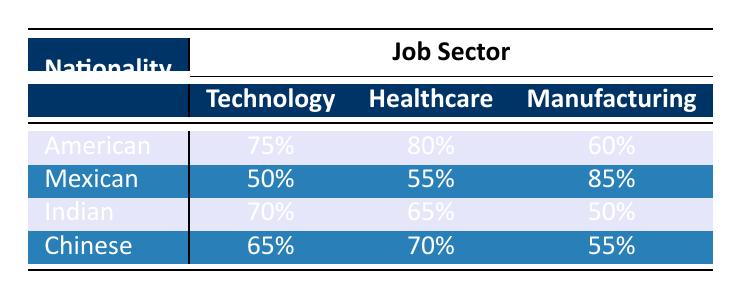What is the participation rate of Americans in the Healthcare sector? From the table, the row for Americans under the Healthcare sector shows a participation rate of 80%.
Answer: 80% Which nationality has the highest participation rate in the Manufacturing sector? In the Manufacturing sector, the participation rates are: American (60%), Mexican (85%), Indian (50%), Chinese (55%). The highest value is 85% for Mexicans.
Answer: Mexican What is the average participation rate for the Technology sector among all nationalities? For the Technology sector, the participation rates are: American (75%), Mexican (50%), Indian (70%), Chinese (65%). The sum is (75 + 50 + 70 + 65) = 260, and there are 4 nationalities, so the average is 260/4 = 65%.
Answer: 65% Is it true that Indians have a higher participation rate in Healthcare than Mexicans? The Healthcare participation rates are: Indian (65%), Mexican (55%). Since 65% is greater than 55%, the statement is true.
Answer: Yes Which job sector has the lowest participation rate for Mexicans? The participation rates for Mexicans are: Technology (50%), Healthcare (55%), Manufacturing (85%). The lowest value is 50% in the Technology sector.
Answer: Technology What is the difference in participation rates between Americans and Indians in the Technology sector? The participation rates are: American (75%) and Indian (70%). The difference is 75% - 70% = 5%.
Answer: 5% Which nationality has the lowest participation rate in the Healthcare sector? The participation rates in Healthcare are: American (80%), Mexican (55%), Indian (65%), Chinese (70%). Among these, the lowest is 55% for Mexicans.
Answer: Mexican If we combine the participation rates for all sectors of Indians, what is the total participation rate? The participation rates for Indians are: Technology (70%), Healthcare (65%), Manufacturing (50%). The sum is (70 + 65 + 50) = 185.
Answer: 185 